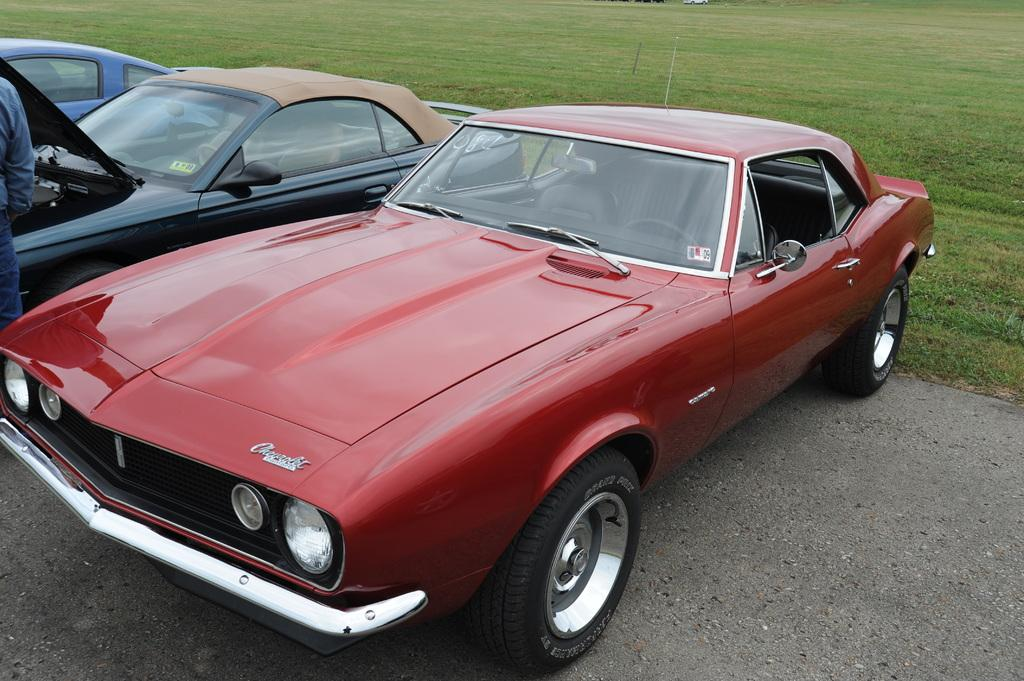What can be seen in the middle of the image? There are three cars in the middle of the image. What type of environment is visible in the background of the image? There is a grassy land in the background of the image. Can you describe the person in the image? There is one person standing on the left side of the image. What type of ticket is the person holding in the image? There is no ticket present in the image; only the person and the cars are visible. How many trucks can be seen in the image? There are no trucks present in the image; only three cars are visible. 